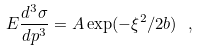Convert formula to latex. <formula><loc_0><loc_0><loc_500><loc_500>E \frac { d ^ { 3 } \sigma } { d p ^ { 3 } } = A \exp ( - \xi ^ { 2 } / 2 b ) \ ,</formula> 